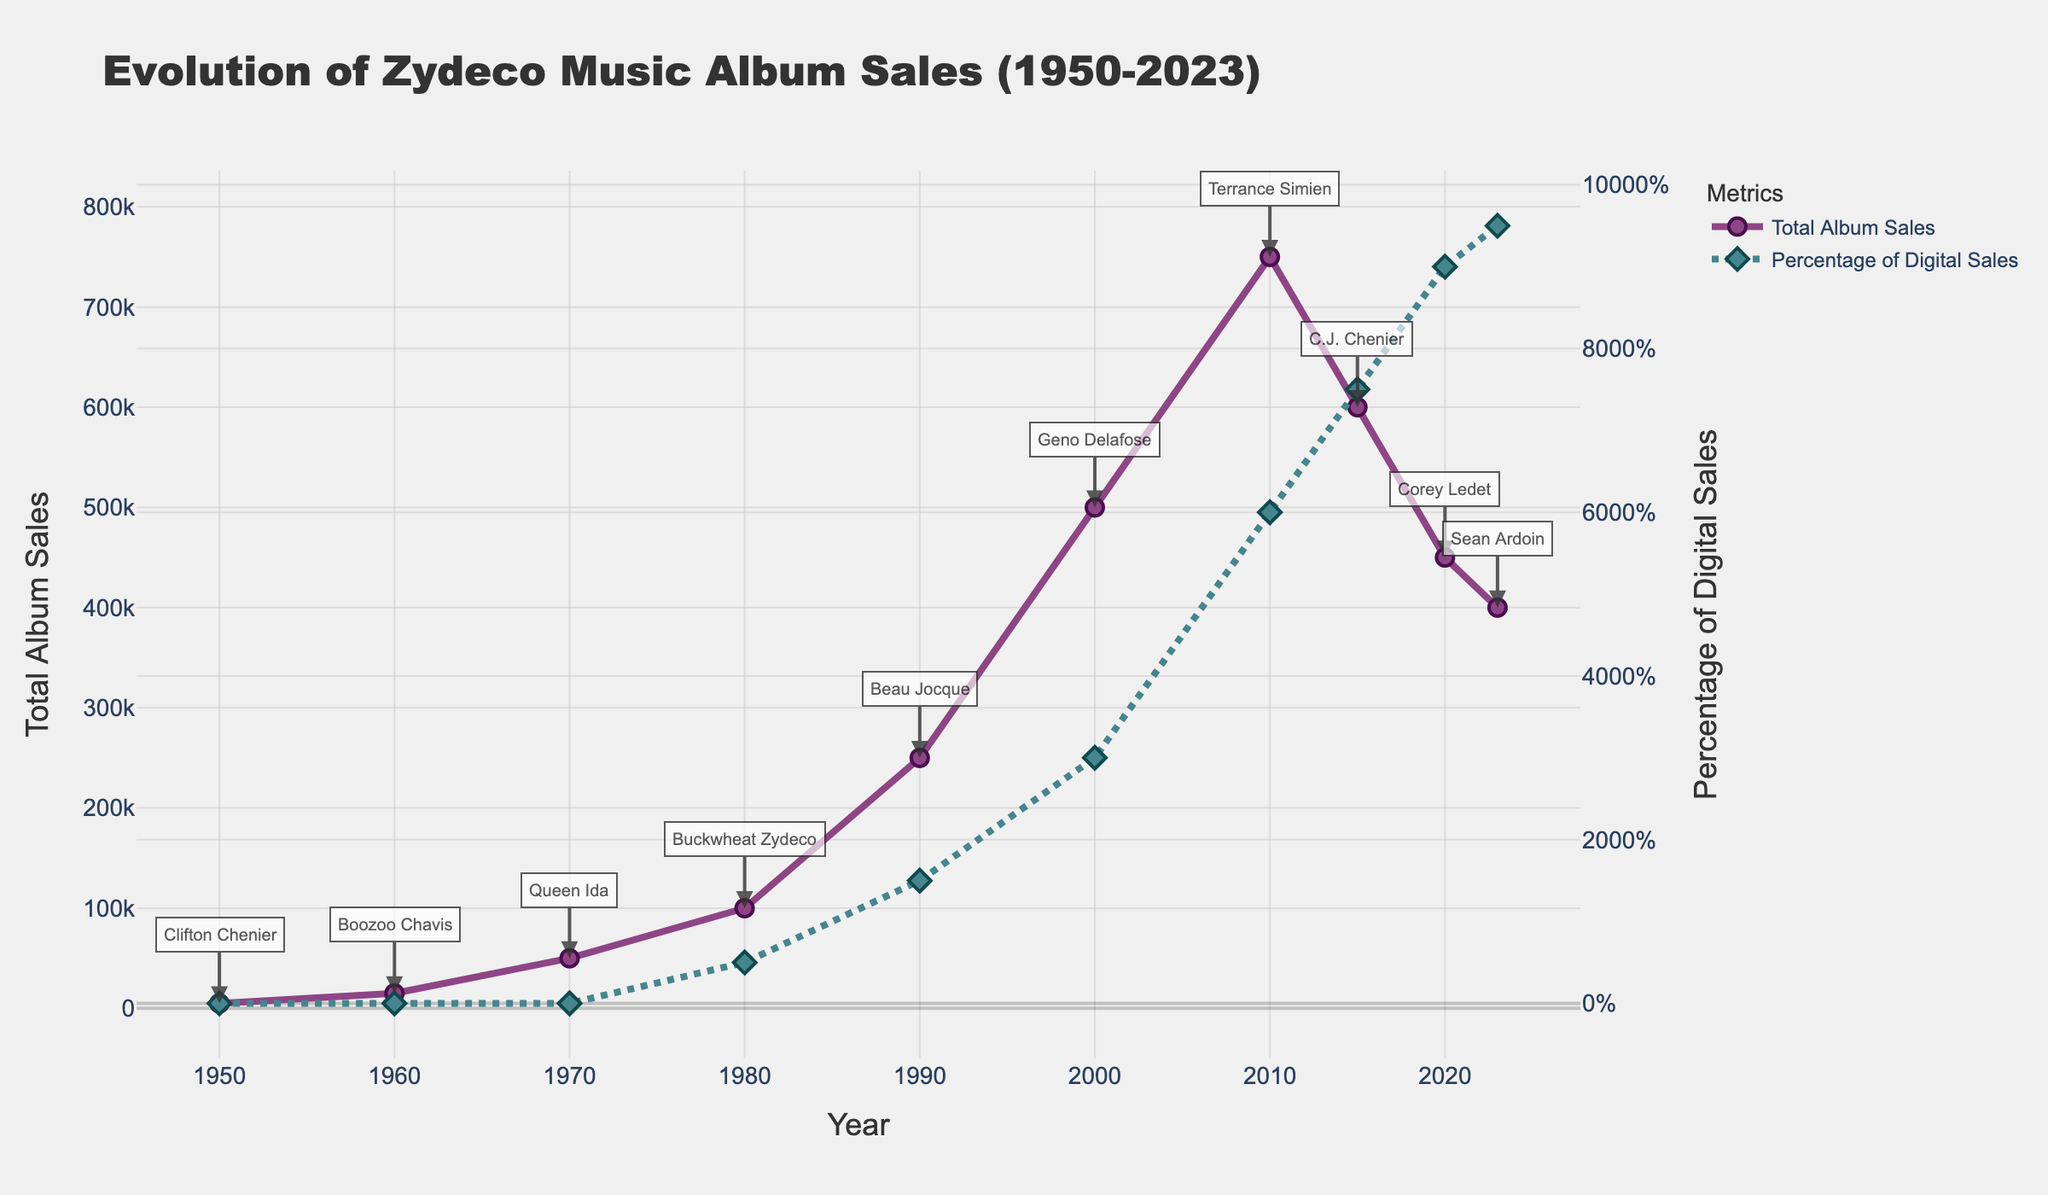What year had the highest total album sales? By examining the total album sales curve on the plot, you can see that it peaks in 2010.
Answer: 2010 How does the percentage of digital sales in 2023 compare to 1980? The plot shows that the percentage of digital sales in 2023 is significantly higher at 95%, compared to only 5% in 1980.
Answer: 2023 has a higher percentage Who was the top selling artist in 2000 and what were the total album sales that year? The annotation near the point on the total album sales curve for the year 2000 indicates that Geno Delafose was the top selling artist with 500,000 album sales.
Answer: Geno Delafose, 500,000 What is the general trend of total album sales from 1950 to 2023? By following the total album sales line on the plot, it shows a rising trend from 1950, peaking around 2010, and then a gradual decline towards 2023.
Answer: Rising then declining Calculate the average total album sales from 1990 to 2020. The total album sales for 1990, 2000, 2010, 2015, and 2020 are 250,000, 500,000, 750,000, 600,000, and 450,000 respectively. Summing these gives 2,550,000, and dividing by 5 gives an average of 510,000.
Answer: 510,000 Between which consecutive years was the drop in album sales the largest? By inspecting the gaps between data points on the total album sales line, the largest drop occurs between 2010 and 2015 (750,000 to 600,000) and between 2015 and 2020 (600,000 to 450,000). The drop between 2015 and 2020 is larger.
Answer: 2015 to 2020 What percentage of sales were digital in 2015, and which artist was the top seller that year? The plot annotation and percentage line for 2015 indicate that 75% of sales were digital, and C.J. Chenier was the top selling artist.
Answer: 75%, C.J. Chenier Compare the highest total album sales and the lowest total album sales depicted in the plot. What can you infer? The highest total album sales were 750,000 in 2010, and the lowest were 5,000 in 1950. This shows a significant growth in popularity and reach of Zydeco music over the decades.
Answer: 750,000 (highest) vs 5,000 (lowest) What was the trend in the percentage of digital sales from 2000 to 2023? By observing the percentage of digital sales line from 2000 onward, it shows a steep upward trend from 30% in 2000 to 95% in 2023, indicating a shift towards digital consumption.
Answer: Increasing rapidly 